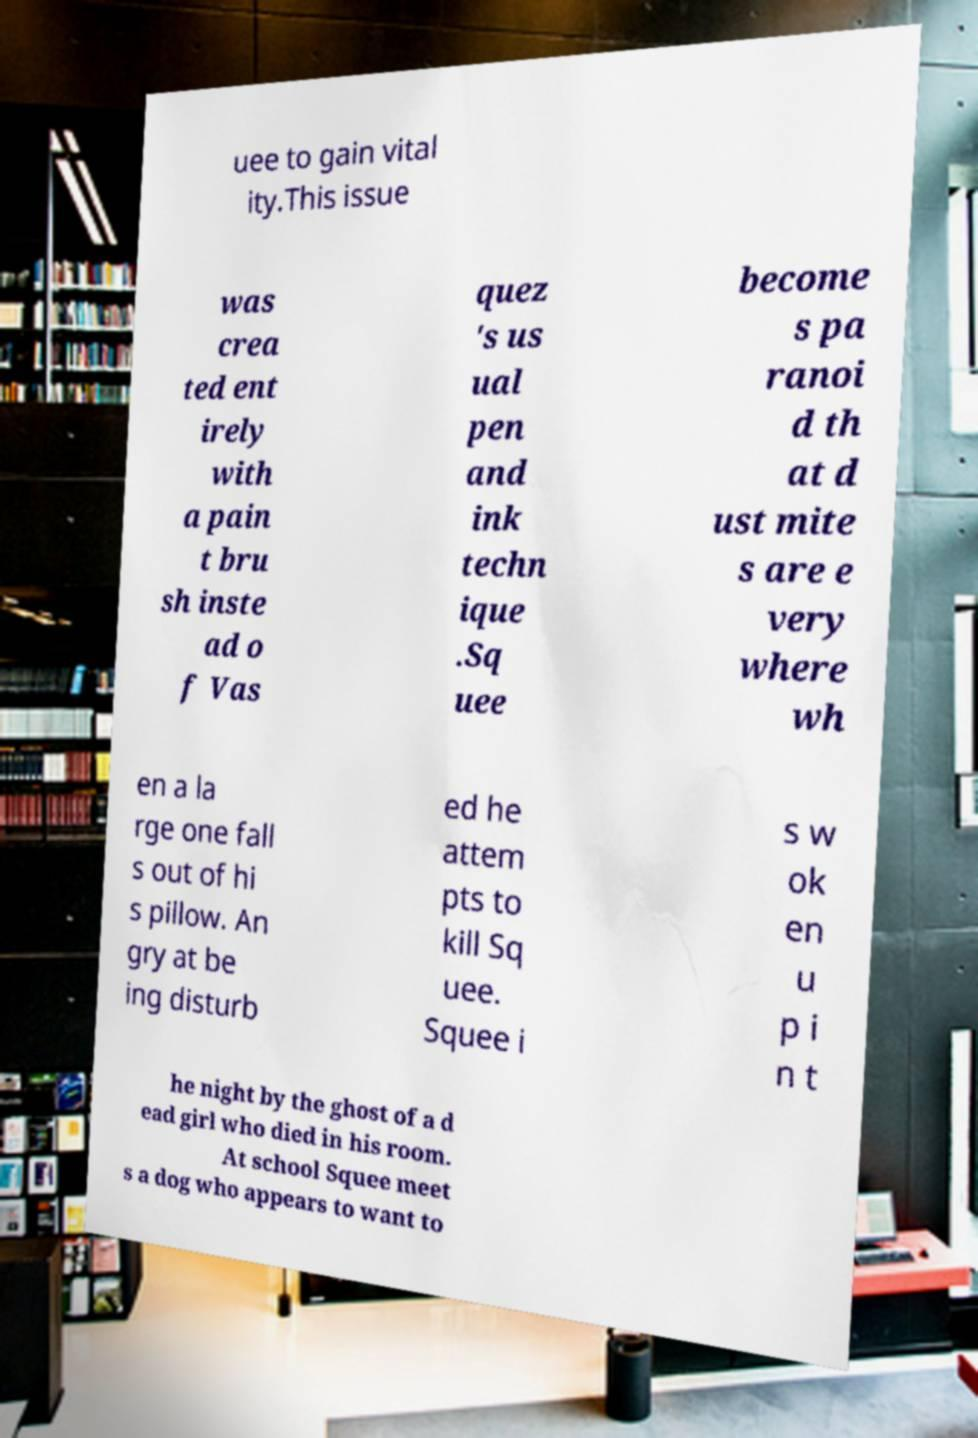There's text embedded in this image that I need extracted. Can you transcribe it verbatim? uee to gain vital ity.This issue was crea ted ent irely with a pain t bru sh inste ad o f Vas quez 's us ual pen and ink techn ique .Sq uee become s pa ranoi d th at d ust mite s are e very where wh en a la rge one fall s out of hi s pillow. An gry at be ing disturb ed he attem pts to kill Sq uee. Squee i s w ok en u p i n t he night by the ghost of a d ead girl who died in his room. At school Squee meet s a dog who appears to want to 